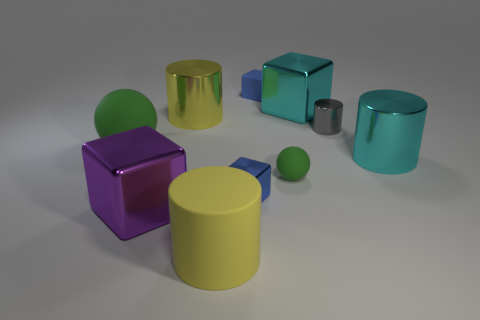How do the textures of the objects compare in this image? The objects in the image showcase a variety of textures. The shiny objects, such as the purple cube and the yellow cylinder, have reflective surfaces that create clear highlights and defined shadows, giving a sense of smoothness and gloss. On the other hand, the matte objects like the large green sphere and the teal cylinder have a more diffused reflection which makes them appear softer and less reflective. 